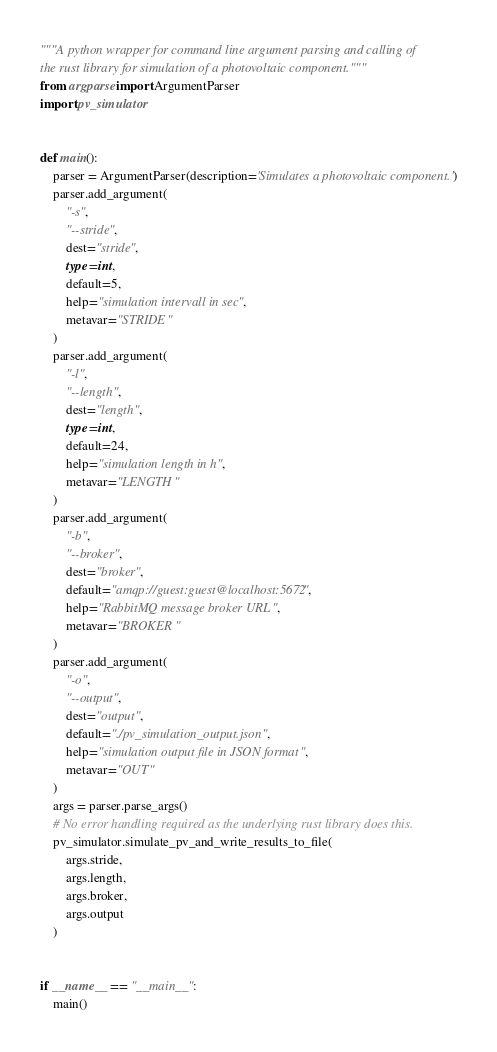<code> <loc_0><loc_0><loc_500><loc_500><_Python_>"""A python wrapper for command line argument parsing and calling of
the rust library for simulation of a photovoltaic component."""
from argparse import ArgumentParser
import pv_simulator


def main():
    parser = ArgumentParser(description='Simulates a photovoltaic component.')
    parser.add_argument(
        "-s",
        "--stride",
        dest="stride",
        type=int,
        default=5,
        help="simulation intervall in sec",
        metavar="STRIDE"
    )
    parser.add_argument(
        "-l",
        "--length",
        dest="length",
        type=int,
        default=24,
        help="simulation length in h",
        metavar="LENGTH"
    )
    parser.add_argument(
        "-b",
        "--broker",
        dest="broker",
        default="amqp://guest:guest@localhost:5672",
        help="RabbitMQ message broker URL",
        metavar="BROKER"
    )
    parser.add_argument(
        "-o",
        "--output",
        dest="output",
        default="./pv_simulation_output.json",
        help="simulation output file in JSON format",
        metavar="OUT"
    )
    args = parser.parse_args()
    # No error handling required as the underlying rust library does this.
    pv_simulator.simulate_pv_and_write_results_to_file(
        args.stride,
        args.length,
        args.broker,
        args.output
    )


if __name__ == "__main__":
    main()
</code> 